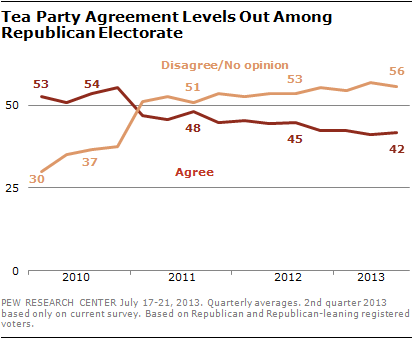Identify some key points in this picture. The two lines crossed in the year 2011. The average of "agree" minus the "red line" is 48.4. 